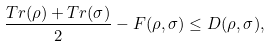Convert formula to latex. <formula><loc_0><loc_0><loc_500><loc_500>\frac { T r ( \rho ) + T r ( \sigma ) } { 2 } - F ( \rho , \sigma ) \leq D ( \rho , \sigma ) ,</formula> 